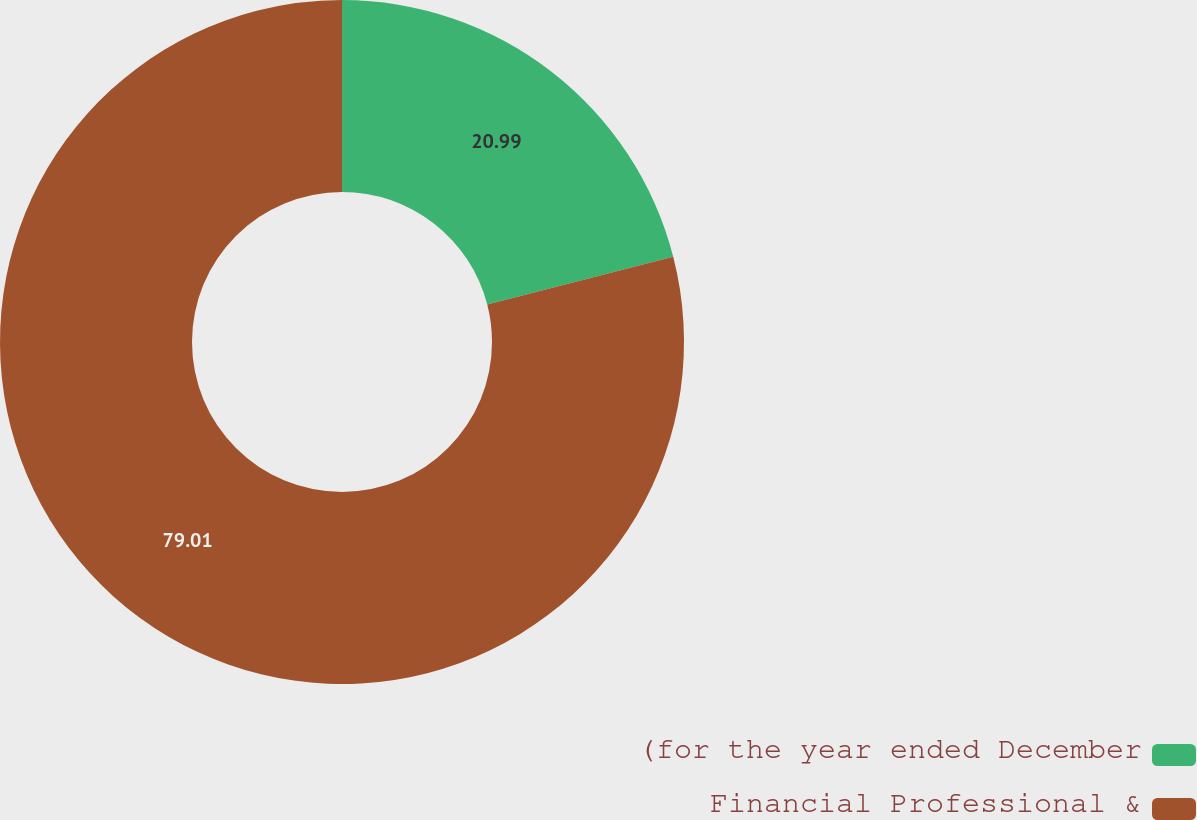Convert chart. <chart><loc_0><loc_0><loc_500><loc_500><pie_chart><fcel>(for the year ended December<fcel>Financial Professional &<nl><fcel>20.99%<fcel>79.01%<nl></chart> 